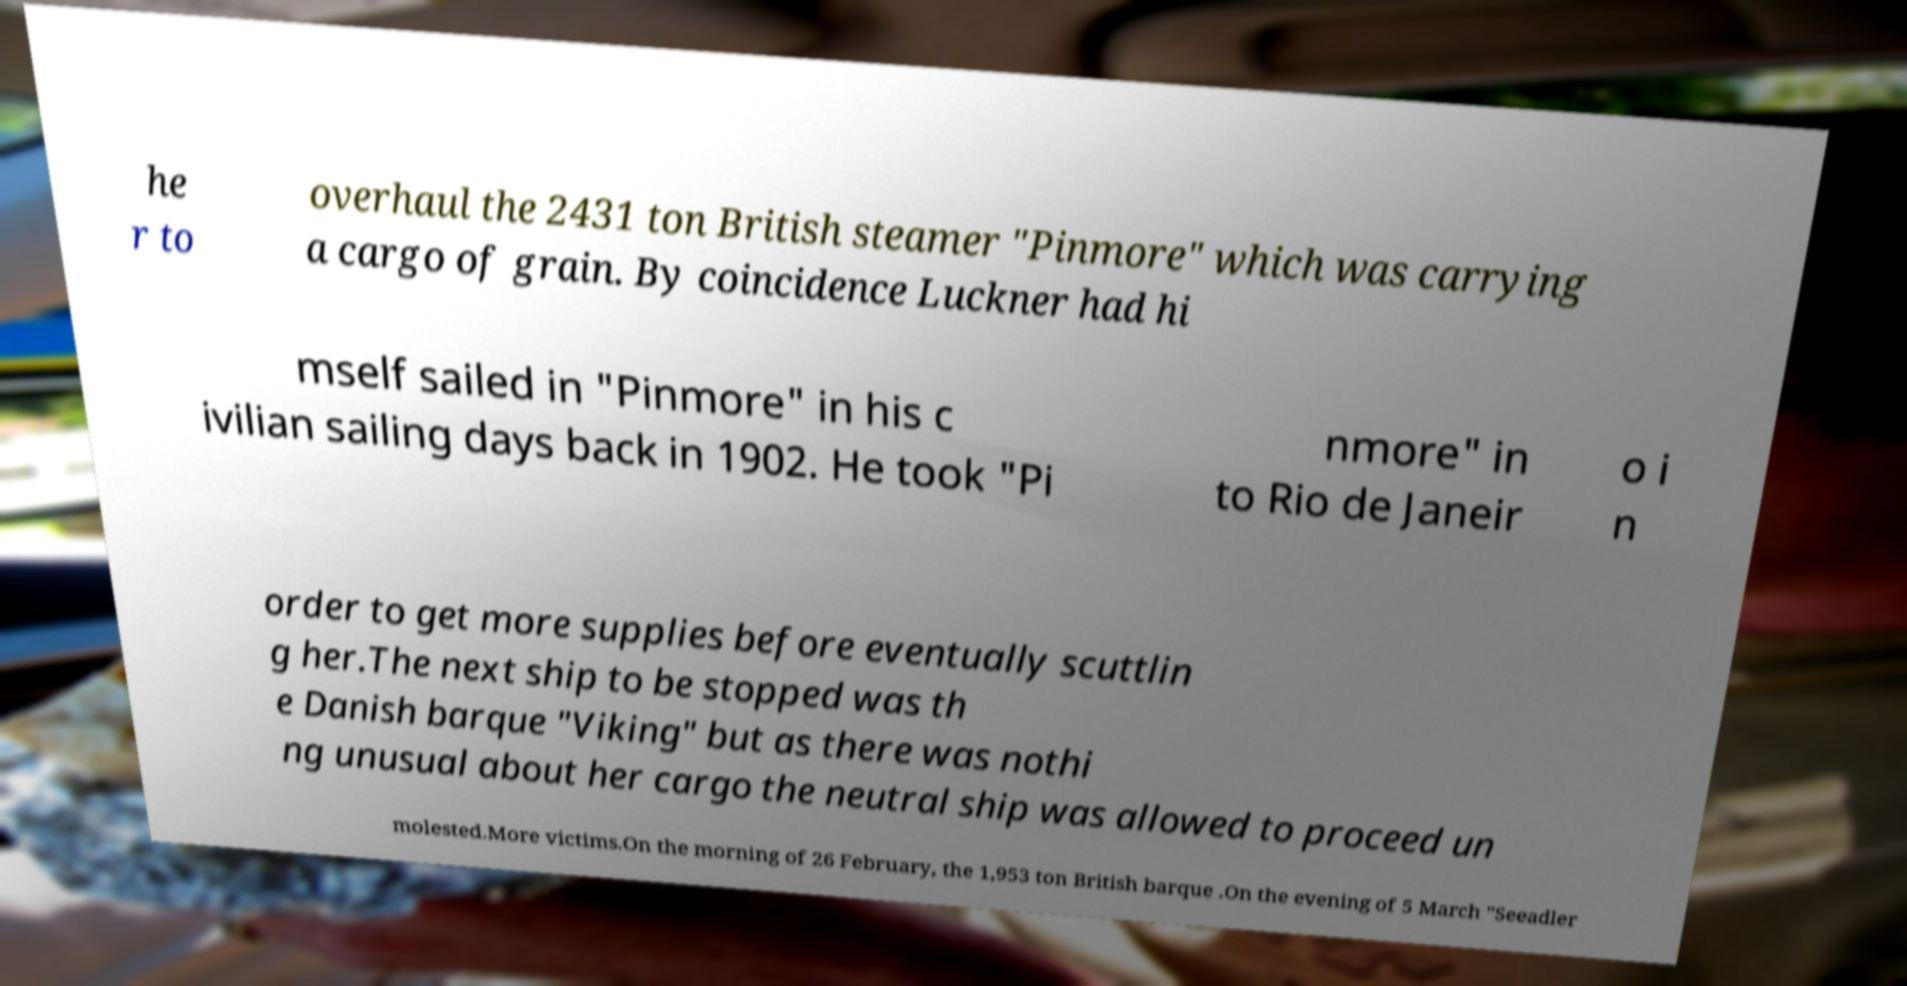Please identify and transcribe the text found in this image. he r to overhaul the 2431 ton British steamer "Pinmore" which was carrying a cargo of grain. By coincidence Luckner had hi mself sailed in "Pinmore" in his c ivilian sailing days back in 1902. He took "Pi nmore" in to Rio de Janeir o i n order to get more supplies before eventually scuttlin g her.The next ship to be stopped was th e Danish barque "Viking" but as there was nothi ng unusual about her cargo the neutral ship was allowed to proceed un molested.More victims.On the morning of 26 February, the 1,953 ton British barque .On the evening of 5 March "Seeadler 